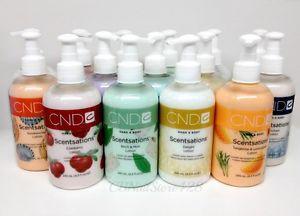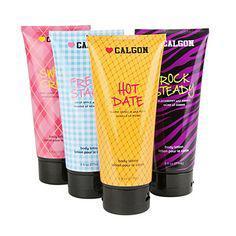The first image is the image on the left, the second image is the image on the right. For the images shown, is this caption "The right image shows just two skincare items side-by-side." true? Answer yes or no. No. The first image is the image on the left, the second image is the image on the right. Analyze the images presented: Is the assertion "At least ten lotion-type products are shown in total." valid? Answer yes or no. Yes. 